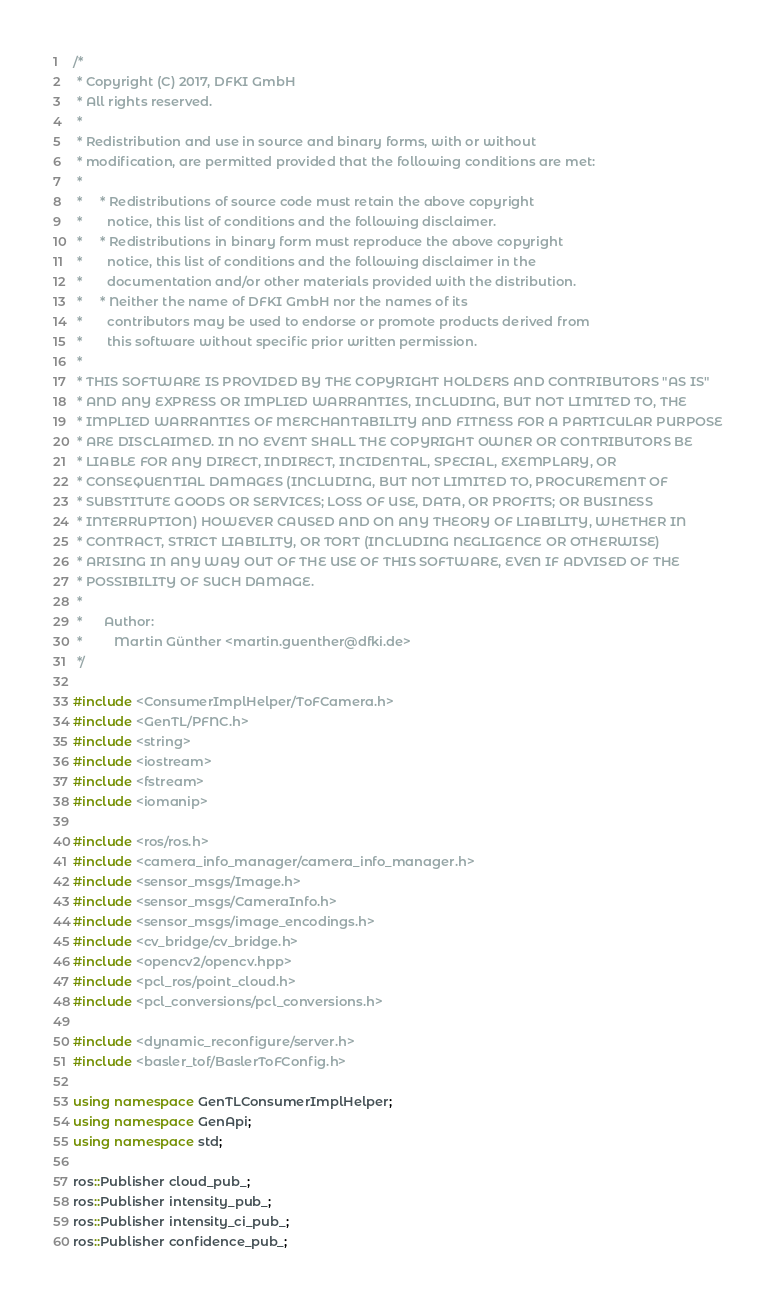Convert code to text. <code><loc_0><loc_0><loc_500><loc_500><_C++_>/*
 * Copyright (C) 2017, DFKI GmbH
 * All rights reserved.
 *
 * Redistribution and use in source and binary forms, with or without
 * modification, are permitted provided that the following conditions are met:
 *
 *     * Redistributions of source code must retain the above copyright
 *       notice, this list of conditions and the following disclaimer.
 *     * Redistributions in binary form must reproduce the above copyright
 *       notice, this list of conditions and the following disclaimer in the
 *       documentation and/or other materials provided with the distribution.
 *     * Neither the name of DFKI GmbH nor the names of its
 *       contributors may be used to endorse or promote products derived from
 *       this software without specific prior written permission.
 *
 * THIS SOFTWARE IS PROVIDED BY THE COPYRIGHT HOLDERS AND CONTRIBUTORS "AS IS"
 * AND ANY EXPRESS OR IMPLIED WARRANTIES, INCLUDING, BUT NOT LIMITED TO, THE
 * IMPLIED WARRANTIES OF MERCHANTABILITY AND FITNESS FOR A PARTICULAR PURPOSE
 * ARE DISCLAIMED. IN NO EVENT SHALL THE COPYRIGHT OWNER OR CONTRIBUTORS BE
 * LIABLE FOR ANY DIRECT, INDIRECT, INCIDENTAL, SPECIAL, EXEMPLARY, OR
 * CONSEQUENTIAL DAMAGES (INCLUDING, BUT NOT LIMITED TO, PROCUREMENT OF
 * SUBSTITUTE GOODS OR SERVICES; LOSS OF USE, DATA, OR PROFITS; OR BUSINESS
 * INTERRUPTION) HOWEVER CAUSED AND ON ANY THEORY OF LIABILITY, WHETHER IN
 * CONTRACT, STRICT LIABILITY, OR TORT (INCLUDING NEGLIGENCE OR OTHERWISE)
 * ARISING IN ANY WAY OUT OF THE USE OF THIS SOFTWARE, EVEN IF ADVISED OF THE
 * POSSIBILITY OF SUCH DAMAGE.
 *
 *      Author:
 *         Martin Günther <martin.guenther@dfki.de>
 */

#include <ConsumerImplHelper/ToFCamera.h>
#include <GenTL/PFNC.h>
#include <string>
#include <iostream>
#include <fstream>
#include <iomanip>

#include <ros/ros.h>
#include <camera_info_manager/camera_info_manager.h>
#include <sensor_msgs/Image.h>
#include <sensor_msgs/CameraInfo.h>
#include <sensor_msgs/image_encodings.h>
#include <cv_bridge/cv_bridge.h>
#include <opencv2/opencv.hpp>
#include <pcl_ros/point_cloud.h>
#include <pcl_conversions/pcl_conversions.h>

#include <dynamic_reconfigure/server.h>
#include <basler_tof/BaslerToFConfig.h>

using namespace GenTLConsumerImplHelper;
using namespace GenApi;
using namespace std;

ros::Publisher cloud_pub_;
ros::Publisher intensity_pub_;
ros::Publisher intensity_ci_pub_;
ros::Publisher confidence_pub_;</code> 